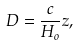Convert formula to latex. <formula><loc_0><loc_0><loc_500><loc_500>D = \frac { c } { H _ { o } } z ,</formula> 